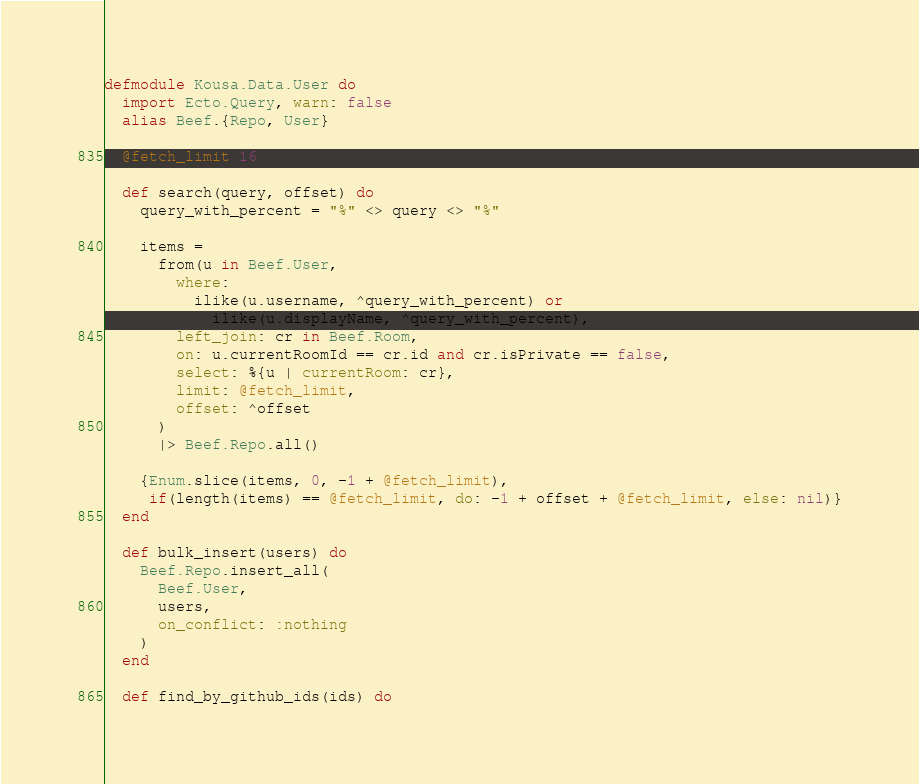Convert code to text. <code><loc_0><loc_0><loc_500><loc_500><_Elixir_>defmodule Kousa.Data.User do
  import Ecto.Query, warn: false
  alias Beef.{Repo, User}

  @fetch_limit 16

  def search(query, offset) do
    query_with_percent = "%" <> query <> "%"

    items =
      from(u in Beef.User,
        where:
          ilike(u.username, ^query_with_percent) or
            ilike(u.displayName, ^query_with_percent),
        left_join: cr in Beef.Room,
        on: u.currentRoomId == cr.id and cr.isPrivate == false,
        select: %{u | currentRoom: cr},
        limit: @fetch_limit,
        offset: ^offset
      )
      |> Beef.Repo.all()

    {Enum.slice(items, 0, -1 + @fetch_limit),
     if(length(items) == @fetch_limit, do: -1 + offset + @fetch_limit, else: nil)}
  end

  def bulk_insert(users) do
    Beef.Repo.insert_all(
      Beef.User,
      users,
      on_conflict: :nothing
    )
  end

  def find_by_github_ids(ids) do</code> 